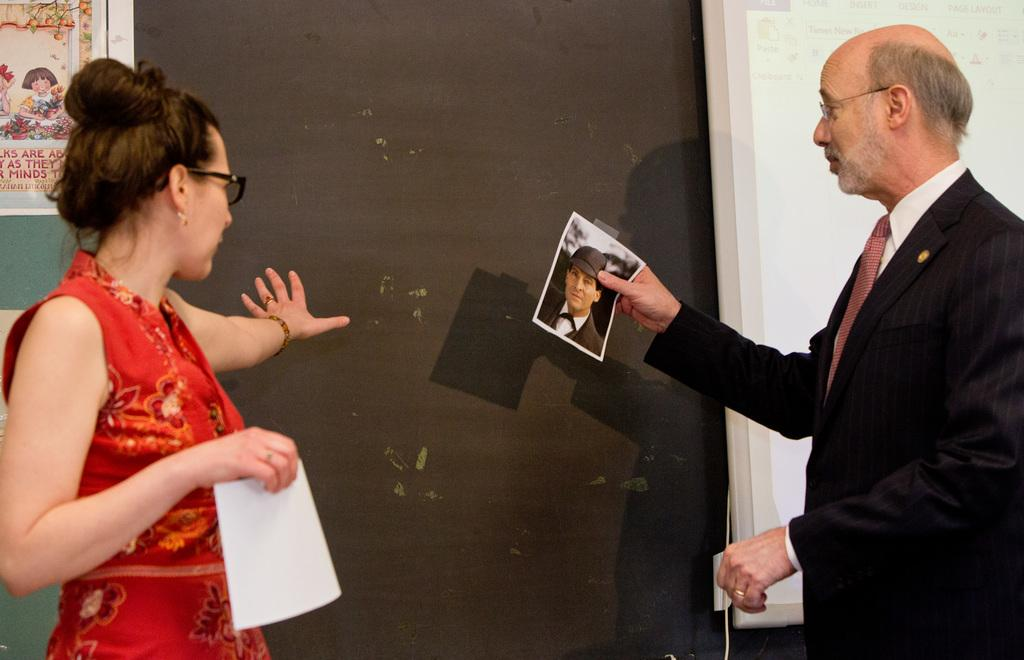Who is present in the image? There is a man and a woman in the image. What are the man and woman holding in the image? The man and woman are holding posters in the image. What can be seen in the background of the image? There is a screen and additional posters in the background of the image. What month is it in the image? The month cannot be determined from the image, as there is no information about the date or time of year. Can you tell me how many yards are visible in the image? There is no yard present in the image; it appears to be an indoor setting with a screen and posters in the background. 